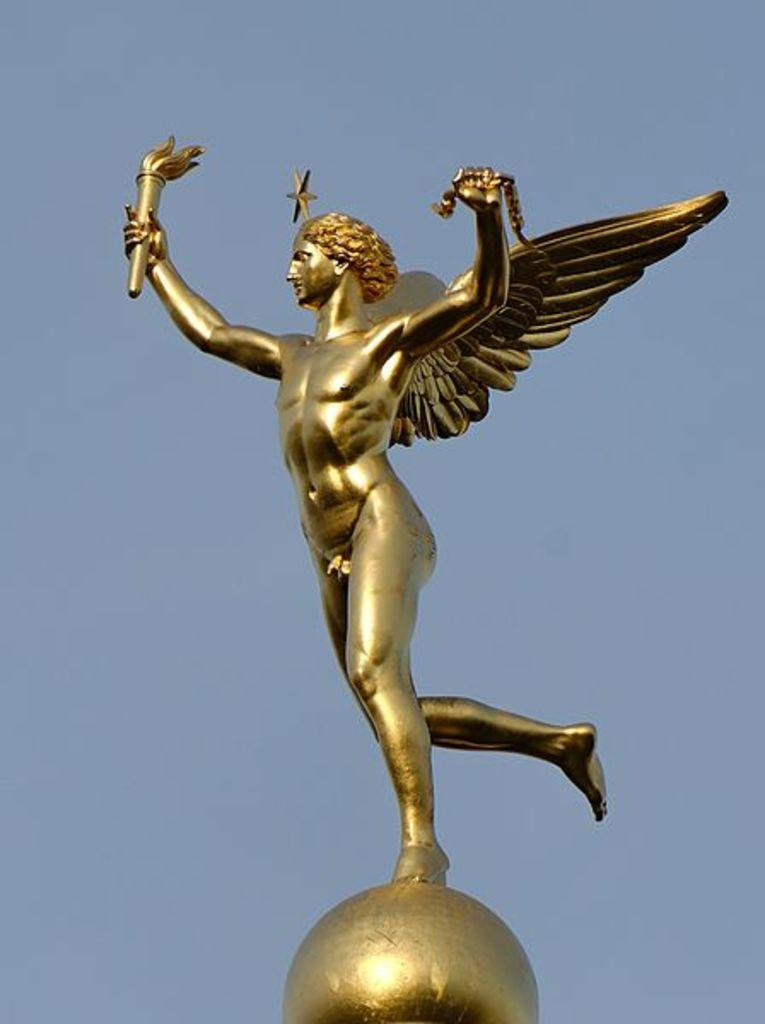What is the main subject in the image? There is a statue in the image. What can be seen in the background of the image? The sky is visible in the background of the image. How many cherries are on the man's head in the image? There is no man or cherries present in the image; it features a statue and the sky in the background. 